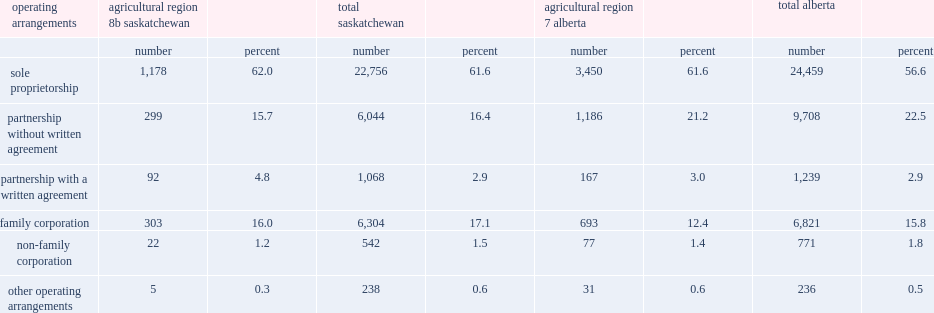In alberta's agricultural region 7, which operating arrangement had more proportion, sole proprietorships or the province as a whole? Sole proprietorship. In alberta's agricultural region 7, which operating arrangement had fewer proportion, incorporated family farms or the province as a whole? Non-family corporation. 